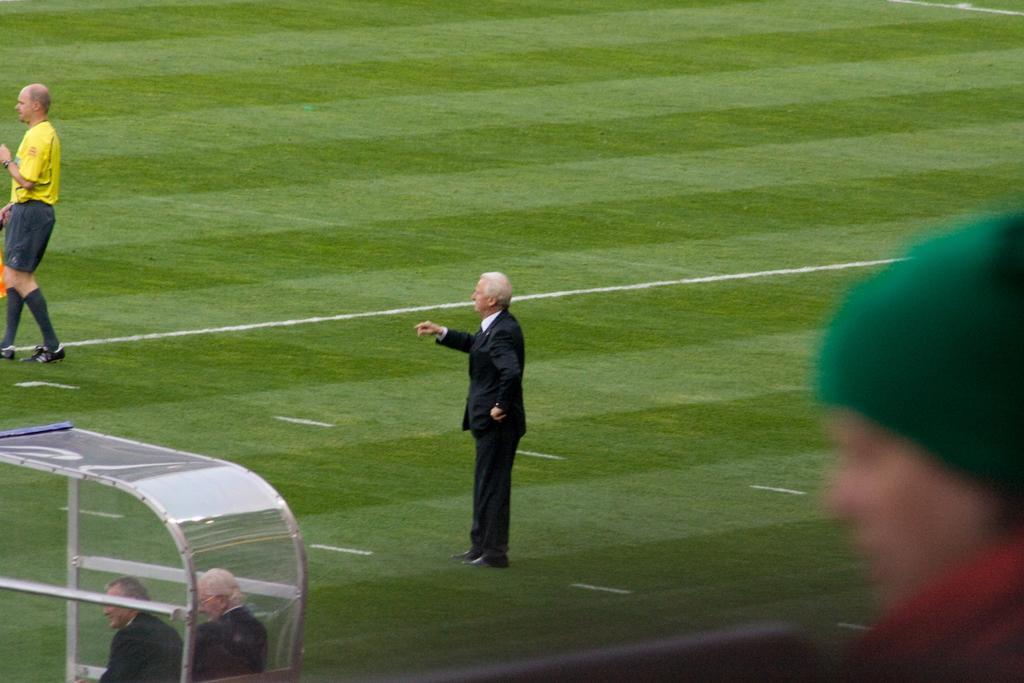Please provide a concise description of this image. In this image a person wearing a black suit is standing on the grass land. Left side a person wearing a yellow shirt is walking on the land. Left bottom there is a cabin in which two persons are there. Right side there is a person wearing green cap and red shirt. 